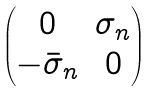<formula> <loc_0><loc_0><loc_500><loc_500>\begin{pmatrix} 0 & \sigma _ { n } \\ - \bar { \sigma } _ { n } & 0 \end{pmatrix}</formula> 